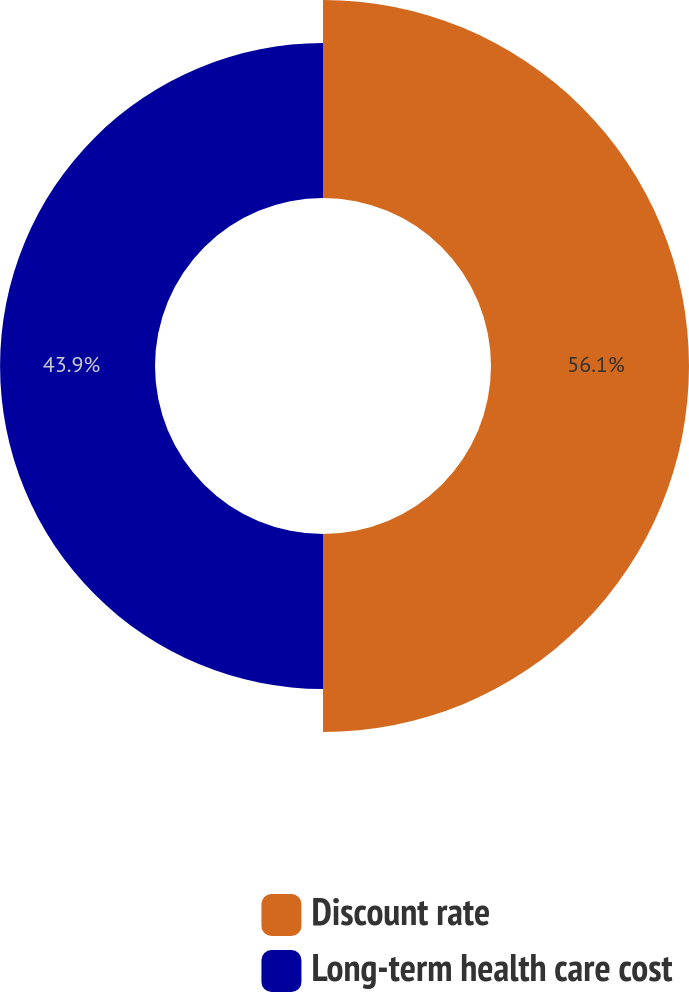<chart> <loc_0><loc_0><loc_500><loc_500><pie_chart><fcel>Discount rate<fcel>Long-term health care cost<nl><fcel>56.1%<fcel>43.9%<nl></chart> 